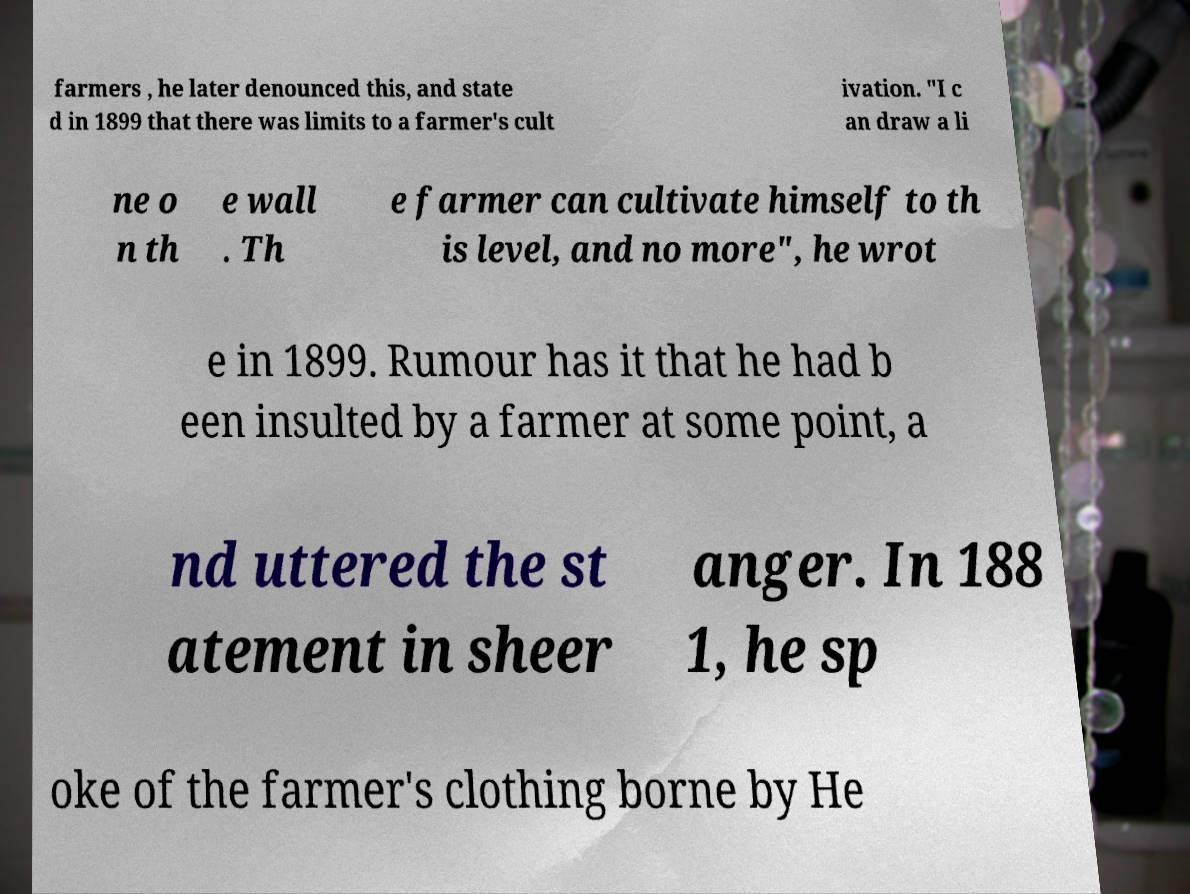Please identify and transcribe the text found in this image. farmers , he later denounced this, and state d in 1899 that there was limits to a farmer's cult ivation. "I c an draw a li ne o n th e wall . Th e farmer can cultivate himself to th is level, and no more", he wrot e in 1899. Rumour has it that he had b een insulted by a farmer at some point, a nd uttered the st atement in sheer anger. In 188 1, he sp oke of the farmer's clothing borne by He 